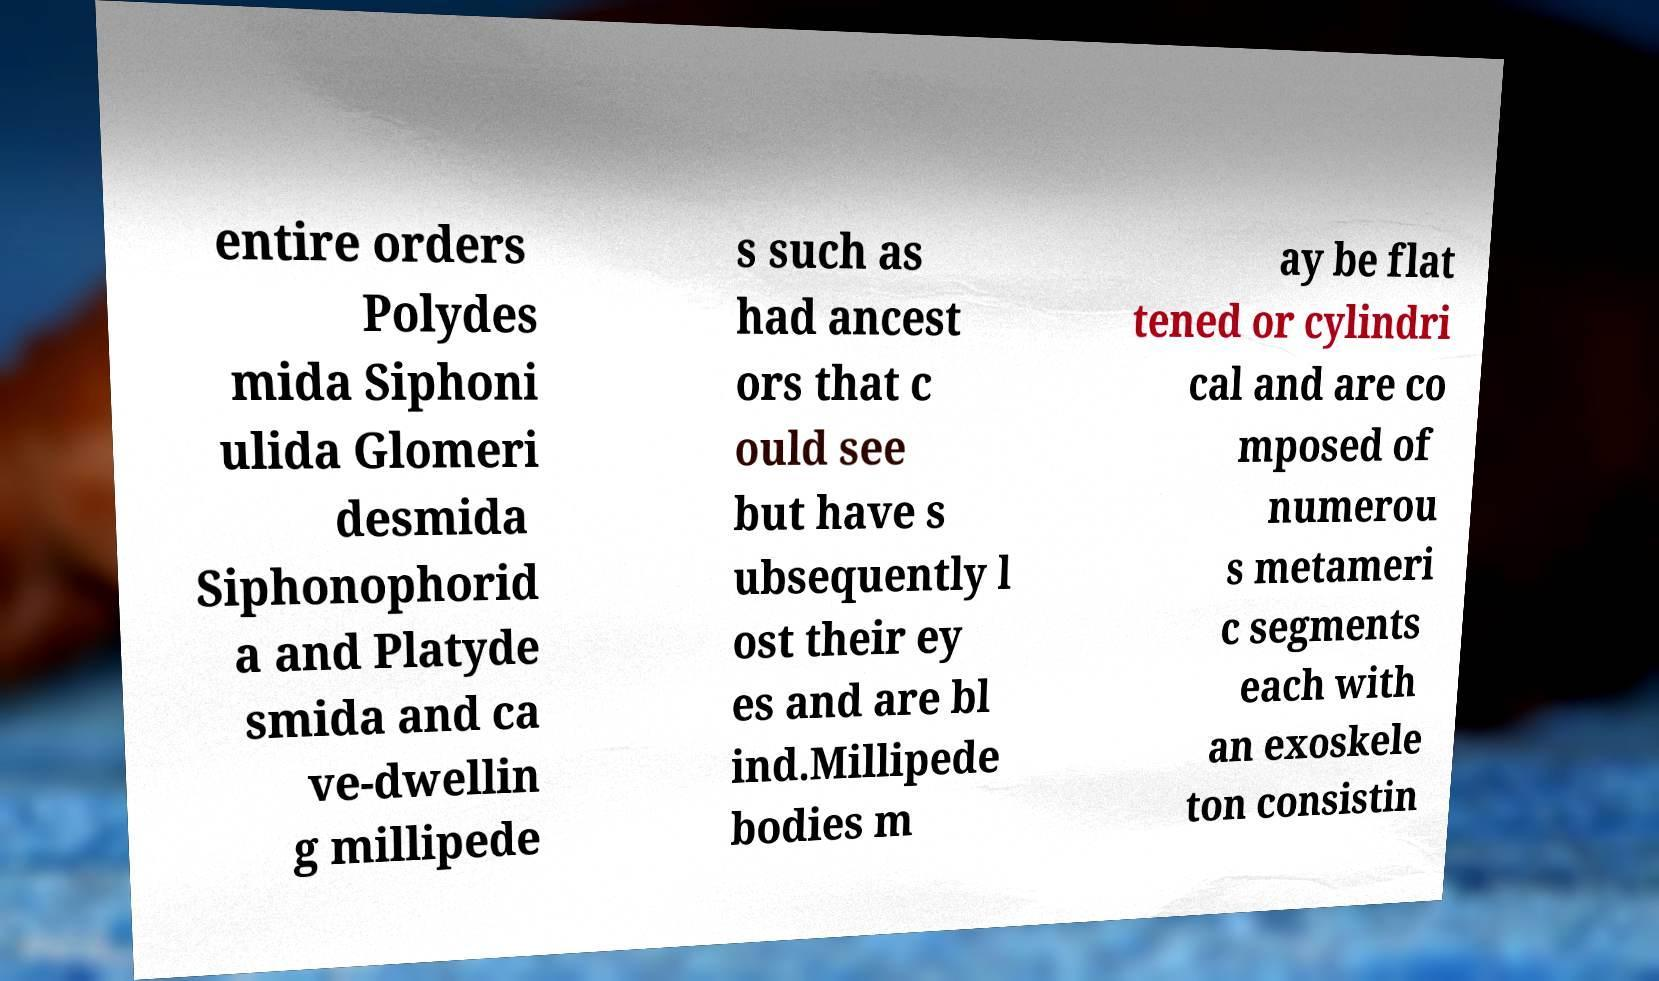Please read and relay the text visible in this image. What does it say? entire orders Polydes mida Siphoni ulida Glomeri desmida Siphonophorid a and Platyde smida and ca ve-dwellin g millipede s such as had ancest ors that c ould see but have s ubsequently l ost their ey es and are bl ind.Millipede bodies m ay be flat tened or cylindri cal and are co mposed of numerou s metameri c segments each with an exoskele ton consistin 